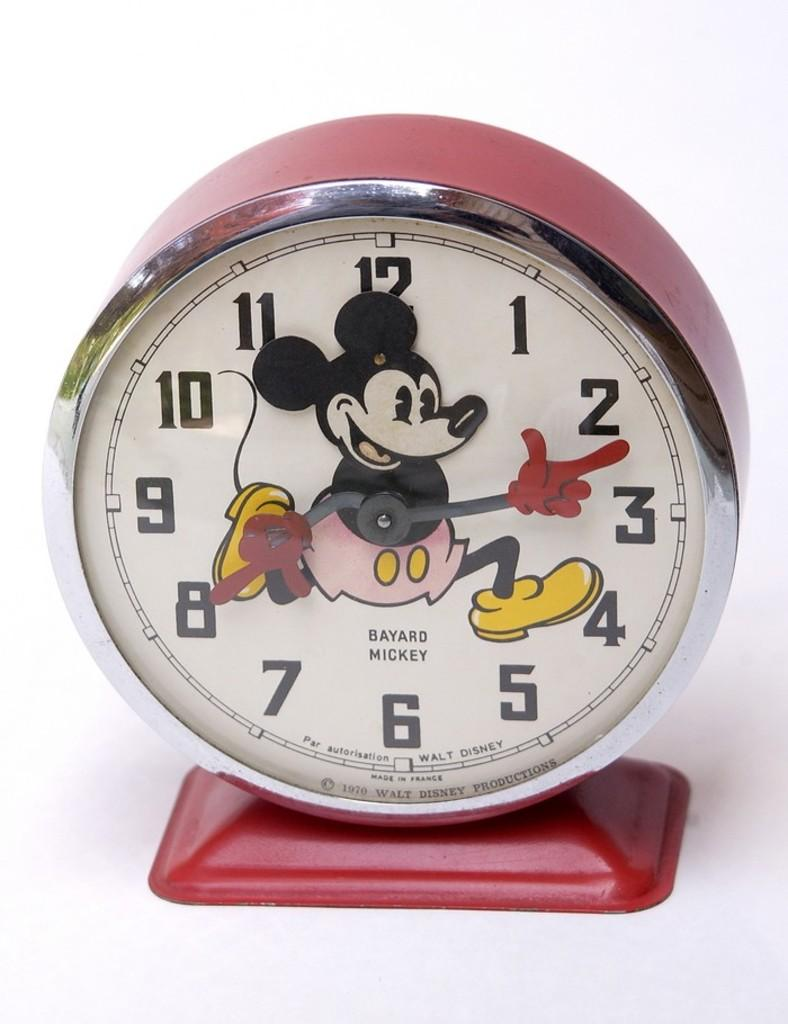<image>
Present a compact description of the photo's key features. A Mickey mouse clock that is pink, in the middle it says Bayard Mickey 